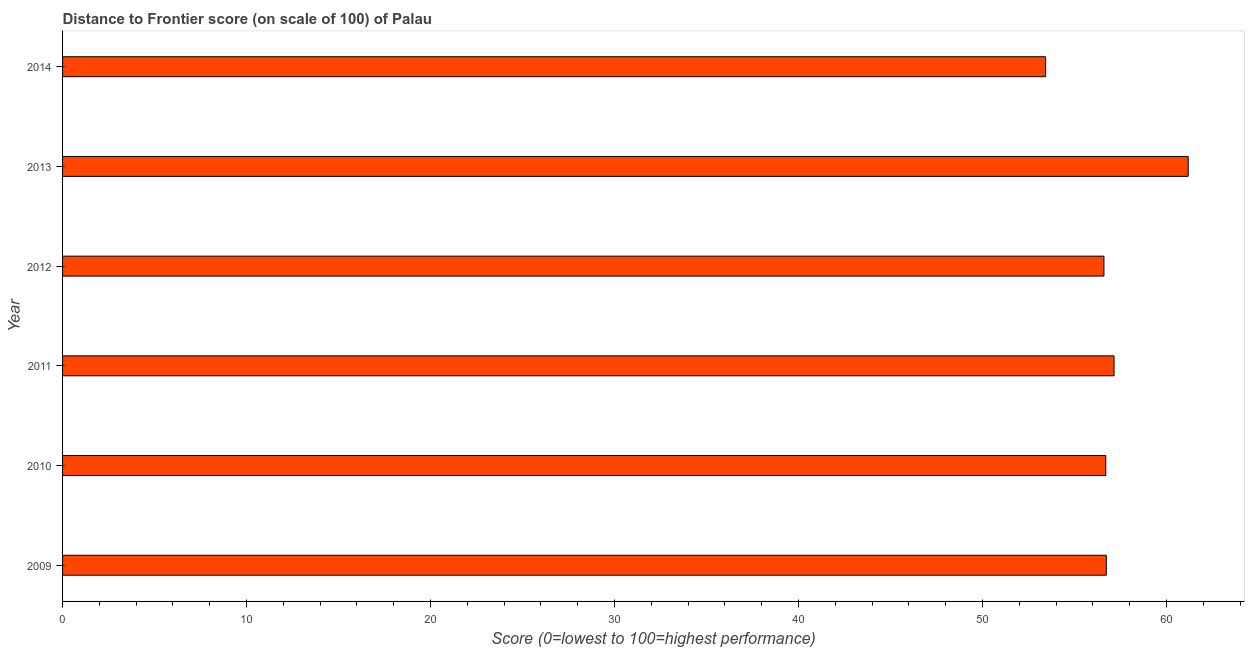Does the graph contain any zero values?
Give a very brief answer. No. What is the title of the graph?
Offer a very short reply. Distance to Frontier score (on scale of 100) of Palau. What is the label or title of the X-axis?
Ensure brevity in your answer.  Score (0=lowest to 100=highest performance). What is the distance to frontier score in 2013?
Your answer should be compact. 61.18. Across all years, what is the maximum distance to frontier score?
Give a very brief answer. 61.18. Across all years, what is the minimum distance to frontier score?
Offer a terse response. 53.43. What is the sum of the distance to frontier score?
Make the answer very short. 341.79. What is the difference between the distance to frontier score in 2011 and 2014?
Keep it short and to the point. 3.72. What is the average distance to frontier score per year?
Give a very brief answer. 56.97. What is the median distance to frontier score?
Give a very brief answer. 56.72. What is the ratio of the distance to frontier score in 2011 to that in 2012?
Provide a short and direct response. 1.01. Is the difference between the distance to frontier score in 2009 and 2011 greater than the difference between any two years?
Give a very brief answer. No. What is the difference between the highest and the second highest distance to frontier score?
Make the answer very short. 4.03. What is the difference between the highest and the lowest distance to frontier score?
Provide a short and direct response. 7.75. In how many years, is the distance to frontier score greater than the average distance to frontier score taken over all years?
Make the answer very short. 2. How many years are there in the graph?
Keep it short and to the point. 6. What is the difference between two consecutive major ticks on the X-axis?
Ensure brevity in your answer.  10. Are the values on the major ticks of X-axis written in scientific E-notation?
Keep it short and to the point. No. What is the Score (0=lowest to 100=highest performance) of 2009?
Your answer should be very brief. 56.73. What is the Score (0=lowest to 100=highest performance) in 2010?
Give a very brief answer. 56.7. What is the Score (0=lowest to 100=highest performance) in 2011?
Your answer should be compact. 57.15. What is the Score (0=lowest to 100=highest performance) in 2012?
Ensure brevity in your answer.  56.6. What is the Score (0=lowest to 100=highest performance) in 2013?
Offer a very short reply. 61.18. What is the Score (0=lowest to 100=highest performance) of 2014?
Offer a terse response. 53.43. What is the difference between the Score (0=lowest to 100=highest performance) in 2009 and 2011?
Your answer should be compact. -0.42. What is the difference between the Score (0=lowest to 100=highest performance) in 2009 and 2012?
Provide a succinct answer. 0.13. What is the difference between the Score (0=lowest to 100=highest performance) in 2009 and 2013?
Keep it short and to the point. -4.45. What is the difference between the Score (0=lowest to 100=highest performance) in 2010 and 2011?
Make the answer very short. -0.45. What is the difference between the Score (0=lowest to 100=highest performance) in 2010 and 2013?
Your response must be concise. -4.48. What is the difference between the Score (0=lowest to 100=highest performance) in 2010 and 2014?
Offer a terse response. 3.27. What is the difference between the Score (0=lowest to 100=highest performance) in 2011 and 2012?
Your response must be concise. 0.55. What is the difference between the Score (0=lowest to 100=highest performance) in 2011 and 2013?
Your answer should be very brief. -4.03. What is the difference between the Score (0=lowest to 100=highest performance) in 2011 and 2014?
Keep it short and to the point. 3.72. What is the difference between the Score (0=lowest to 100=highest performance) in 2012 and 2013?
Provide a succinct answer. -4.58. What is the difference between the Score (0=lowest to 100=highest performance) in 2012 and 2014?
Your answer should be compact. 3.17. What is the difference between the Score (0=lowest to 100=highest performance) in 2013 and 2014?
Your answer should be very brief. 7.75. What is the ratio of the Score (0=lowest to 100=highest performance) in 2009 to that in 2010?
Your answer should be compact. 1. What is the ratio of the Score (0=lowest to 100=highest performance) in 2009 to that in 2011?
Give a very brief answer. 0.99. What is the ratio of the Score (0=lowest to 100=highest performance) in 2009 to that in 2012?
Offer a terse response. 1. What is the ratio of the Score (0=lowest to 100=highest performance) in 2009 to that in 2013?
Your answer should be compact. 0.93. What is the ratio of the Score (0=lowest to 100=highest performance) in 2009 to that in 2014?
Offer a terse response. 1.06. What is the ratio of the Score (0=lowest to 100=highest performance) in 2010 to that in 2013?
Offer a very short reply. 0.93. What is the ratio of the Score (0=lowest to 100=highest performance) in 2010 to that in 2014?
Your response must be concise. 1.06. What is the ratio of the Score (0=lowest to 100=highest performance) in 2011 to that in 2013?
Your answer should be compact. 0.93. What is the ratio of the Score (0=lowest to 100=highest performance) in 2011 to that in 2014?
Provide a short and direct response. 1.07. What is the ratio of the Score (0=lowest to 100=highest performance) in 2012 to that in 2013?
Your response must be concise. 0.93. What is the ratio of the Score (0=lowest to 100=highest performance) in 2012 to that in 2014?
Your answer should be compact. 1.06. What is the ratio of the Score (0=lowest to 100=highest performance) in 2013 to that in 2014?
Ensure brevity in your answer.  1.15. 